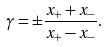<formula> <loc_0><loc_0><loc_500><loc_500>\gamma = \pm \frac { x _ { + } + x _ { - } } { x _ { + } - x _ { - } } .</formula> 